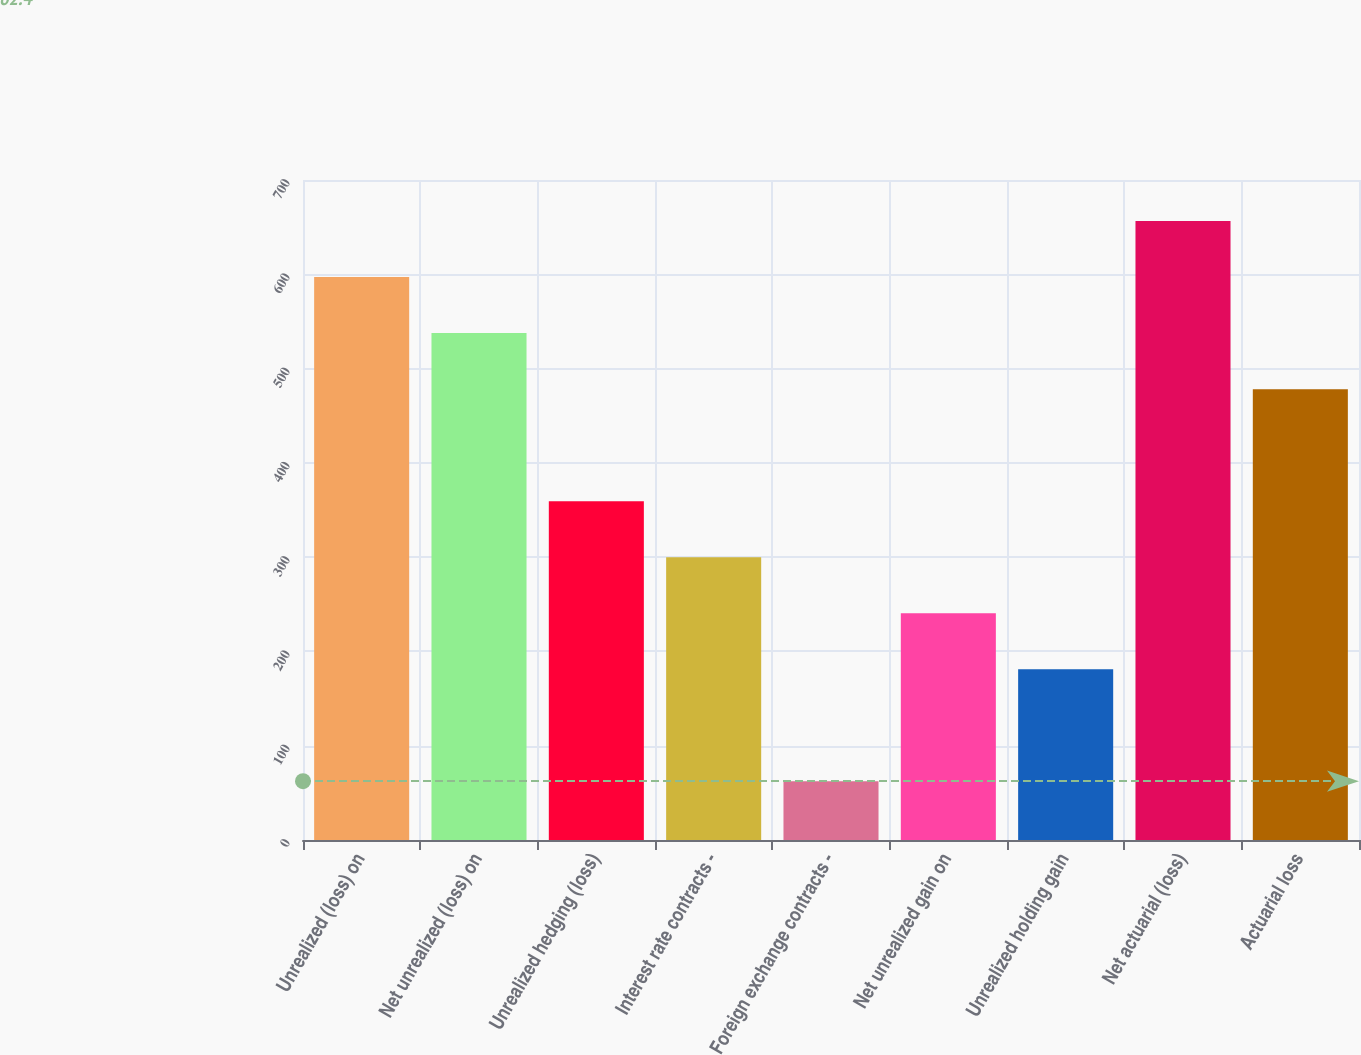<chart> <loc_0><loc_0><loc_500><loc_500><bar_chart><fcel>Unrealized (loss) on<fcel>Net unrealized (loss) on<fcel>Unrealized hedging (loss)<fcel>Interest rate contracts -<fcel>Foreign exchange contracts -<fcel>Net unrealized gain on<fcel>Unrealized holding gain<fcel>Net actuarial (loss)<fcel>Actuarial loss<nl><fcel>597<fcel>537.6<fcel>359.4<fcel>300<fcel>62.4<fcel>240.6<fcel>181.2<fcel>656.4<fcel>478.2<nl></chart> 